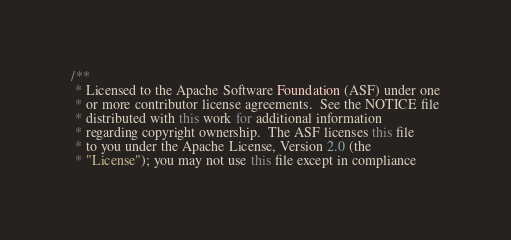Convert code to text. <code><loc_0><loc_0><loc_500><loc_500><_Java_>/**
 * Licensed to the Apache Software Foundation (ASF) under one
 * or more contributor license agreements.  See the NOTICE file
 * distributed with this work for additional information
 * regarding copyright ownership.  The ASF licenses this file
 * to you under the Apache License, Version 2.0 (the
 * "License"); you may not use this file except in compliance</code> 